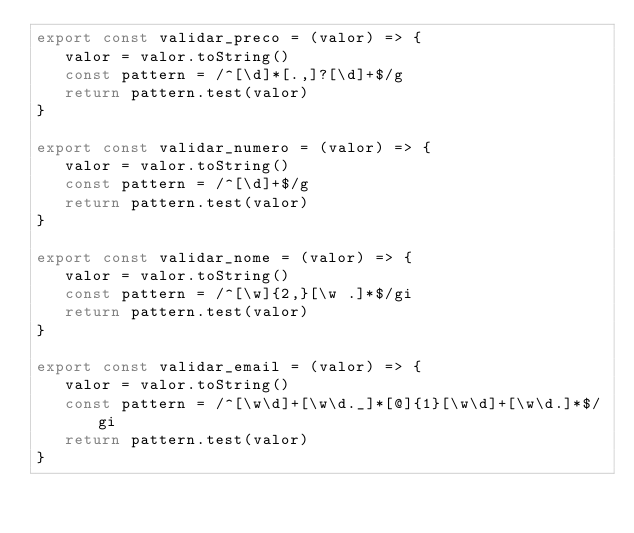Convert code to text. <code><loc_0><loc_0><loc_500><loc_500><_JavaScript_>export const validar_preco = (valor) => {
   valor = valor.toString()
   const pattern = /^[\d]*[.,]?[\d]+$/g
   return pattern.test(valor)
}

export const validar_numero = (valor) => {
   valor = valor.toString()
   const pattern = /^[\d]+$/g
   return pattern.test(valor)
}

export const validar_nome = (valor) => {
   valor = valor.toString()
   const pattern = /^[\w]{2,}[\w .]*$/gi
   return pattern.test(valor)
}

export const validar_email = (valor) => {
   valor = valor.toString()
   const pattern = /^[\w\d]+[\w\d._]*[@]{1}[\w\d]+[\w\d.]*$/gi
   return pattern.test(valor)
}</code> 